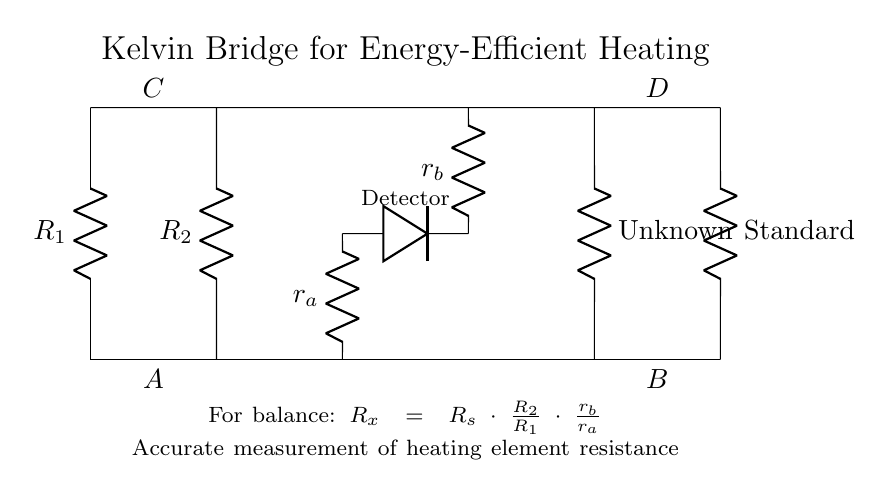What are the resistances labeled in the circuit? The circuit shows four resistances: R1, R2, R_x (unknown), and R_s (standard). These labels can be observed directly from the diagram in their respective positions on the arms of the bridge.
Answer: R1, R2, R_x, R_s What is the purpose of the Detector in the Kelvin Bridge? The Detector is used to identify the balance point of the circuit where there is no voltage across it, which indicates that the unknown resistance matches the standard resistance ratio. Its position in the circuit informs us that it monitors the current flow between the resistive arms.
Answer: To find balance How is the unknown resistance calculated? The unknown resistance R_x is calculated using the formula R_x = R_s multiplied by the ratio of R2 to R1, and then adjusted by the ratio of r_b to r_a. This relationship is specifically defined in the circuit's explanation label.
Answer: R_x = R_s * (R2/R1) * (r_b/r_a) What does the 'r_a' and 'r_b' represent in this circuit? 'r_a' and 'r_b' are additional resistors that allow for fine-tuning of the balance equation. They are part of the middle connections in the Kelvin Bridge setup, which adjust the circuit to achieve the balance needed for accurate resistance measurement.
Answer: Fine-tuning resistors What is the configuration type of this circuit? This is a Wheatstone bridge configuration, specifically designed as a Kelvin bridge, which is used for precise measurements of very low resistances in this context. The arrangement and use of multiple resistance arms confirm this structure.
Answer: Wheatstone bridge 